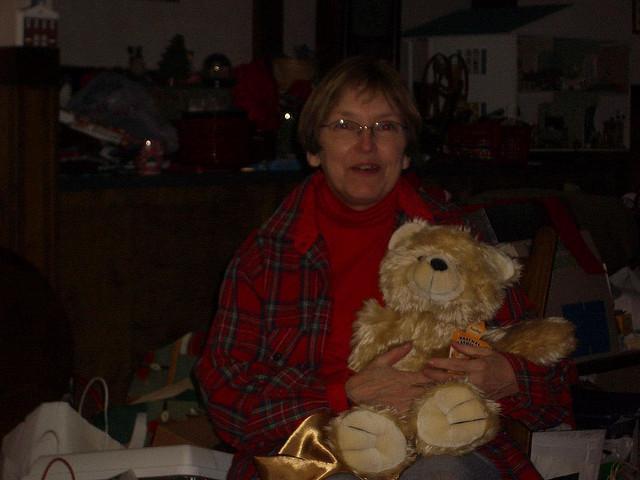How many bears are in the image?
Give a very brief answer. 1. How many people are there?
Give a very brief answer. 1. How many stuffed animals in the picture?
Give a very brief answer. 1. How many teddy bears are in the picture?
Give a very brief answer. 1. How many bears are there in the picture?
Give a very brief answer. 1. How many stuffed animals are pictured?
Give a very brief answer. 1. 